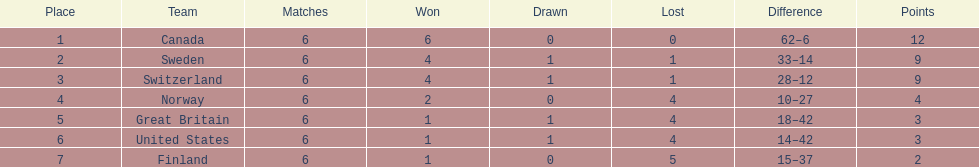How many teams have only one match victory? 3. 